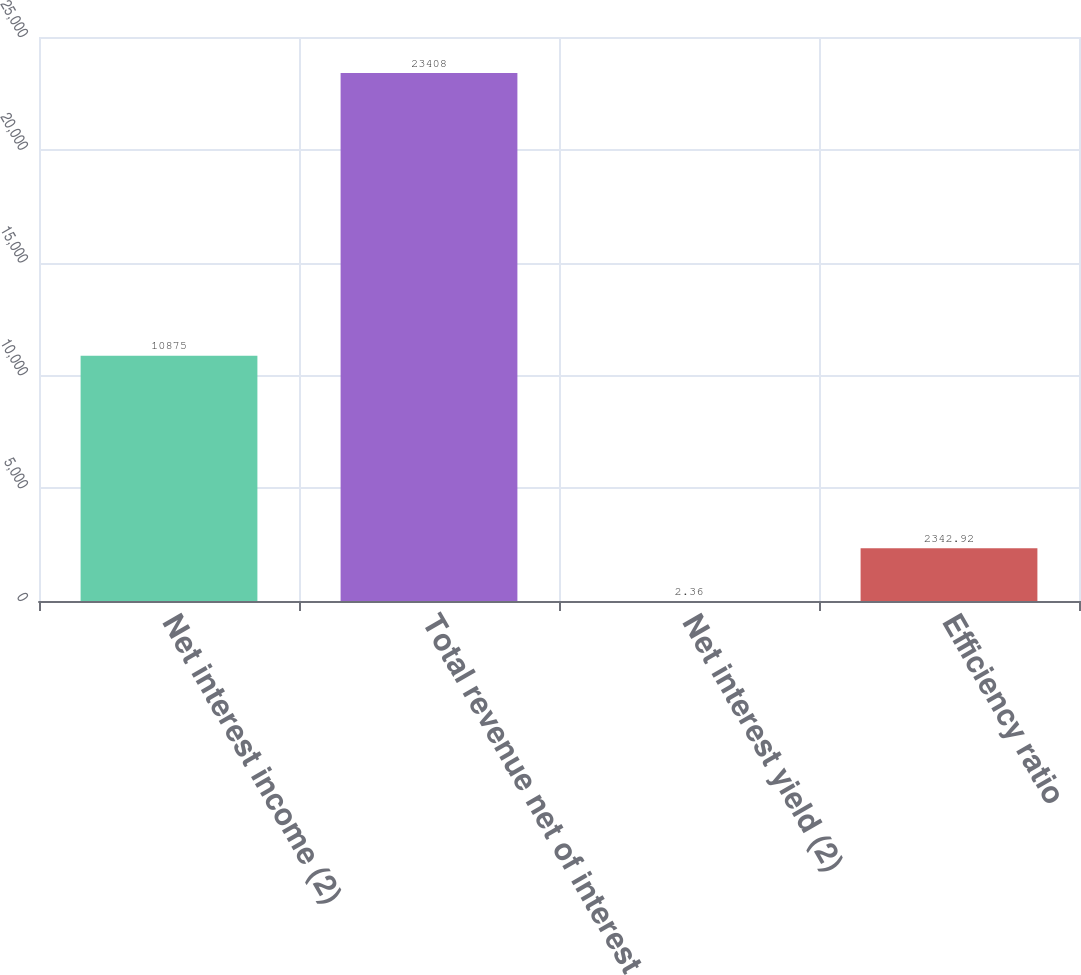Convert chart to OTSL. <chart><loc_0><loc_0><loc_500><loc_500><bar_chart><fcel>Net interest income (2)<fcel>Total revenue net of interest<fcel>Net interest yield (2)<fcel>Efficiency ratio<nl><fcel>10875<fcel>23408<fcel>2.36<fcel>2342.92<nl></chart> 